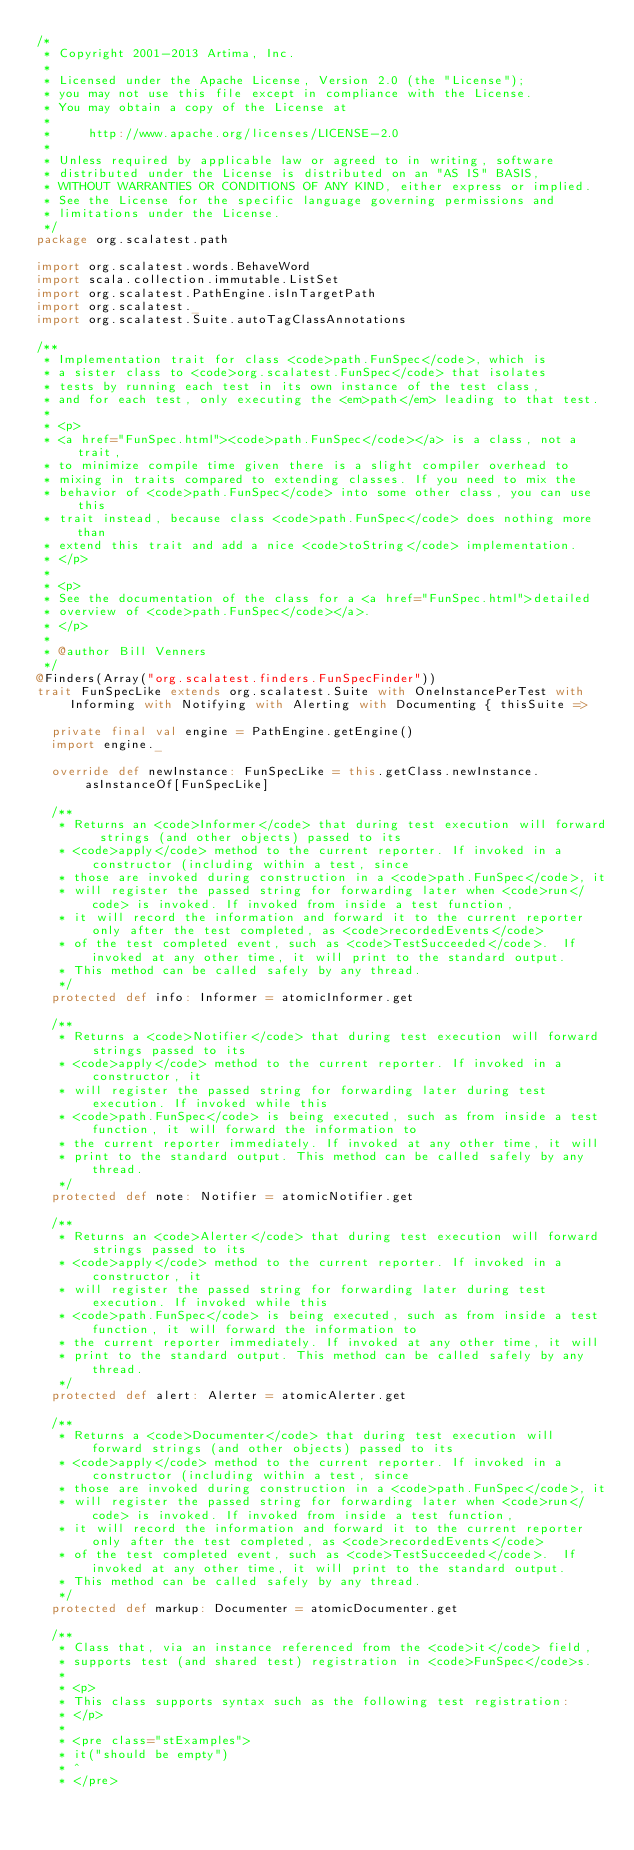Convert code to text. <code><loc_0><loc_0><loc_500><loc_500><_Scala_>/*
 * Copyright 2001-2013 Artima, Inc.
 *
 * Licensed under the Apache License, Version 2.0 (the "License");
 * you may not use this file except in compliance with the License.
 * You may obtain a copy of the License at
 *
 *     http://www.apache.org/licenses/LICENSE-2.0
 *
 * Unless required by applicable law or agreed to in writing, software
 * distributed under the License is distributed on an "AS IS" BASIS,
 * WITHOUT WARRANTIES OR CONDITIONS OF ANY KIND, either express or implied.
 * See the License for the specific language governing permissions and
 * limitations under the License.
 */
package org.scalatest.path

import org.scalatest.words.BehaveWord
import scala.collection.immutable.ListSet
import org.scalatest.PathEngine.isInTargetPath
import org.scalatest._
import org.scalatest.Suite.autoTagClassAnnotations

/**
 * Implementation trait for class <code>path.FunSpec</code>, which is
 * a sister class to <code>org.scalatest.FunSpec</code> that isolates
 * tests by running each test in its own instance of the test class,
 * and for each test, only executing the <em>path</em> leading to that test.
 * 
 * <p>
 * <a href="FunSpec.html"><code>path.FunSpec</code></a> is a class, not a trait,
 * to minimize compile time given there is a slight compiler overhead to
 * mixing in traits compared to extending classes. If you need to mix the
 * behavior of <code>path.FunSpec</code> into some other class, you can use this
 * trait instead, because class <code>path.FunSpec</code> does nothing more than
 * extend this trait and add a nice <code>toString</code> implementation.
 * </p>
 *
 * <p>
 * See the documentation of the class for a <a href="FunSpec.html">detailed
 * overview of <code>path.FunSpec</code></a>.
 * </p>
 *
 * @author Bill Venners
 */
@Finders(Array("org.scalatest.finders.FunSpecFinder"))
trait FunSpecLike extends org.scalatest.Suite with OneInstancePerTest with Informing with Notifying with Alerting with Documenting { thisSuite =>
  
  private final val engine = PathEngine.getEngine()
  import engine._

  override def newInstance: FunSpecLike = this.getClass.newInstance.asInstanceOf[FunSpecLike]

  /**
   * Returns an <code>Informer</code> that during test execution will forward strings (and other objects) passed to its
   * <code>apply</code> method to the current reporter. If invoked in a constructor (including within a test, since
   * those are invoked during construction in a <code>path.FunSpec</code>, it
   * will register the passed string for forwarding later when <code>run</code> is invoked. If invoked from inside a test function,
   * it will record the information and forward it to the current reporter only after the test completed, as <code>recordedEvents</code>
   * of the test completed event, such as <code>TestSucceeded</code>.  If invoked at any other time, it will print to the standard output.
   * This method can be called safely by any thread.
   */
  protected def info: Informer = atomicInformer.get

  /**
   * Returns a <code>Notifier</code> that during test execution will forward strings passed to its
   * <code>apply</code> method to the current reporter. If invoked in a constructor, it
   * will register the passed string for forwarding later during test execution. If invoked while this
   * <code>path.FunSpec</code> is being executed, such as from inside a test function, it will forward the information to
   * the current reporter immediately. If invoked at any other time, it will
   * print to the standard output. This method can be called safely by any thread.
   */
  protected def note: Notifier = atomicNotifier.get

  /**
   * Returns an <code>Alerter</code> that during test execution will forward strings passed to its
   * <code>apply</code> method to the current reporter. If invoked in a constructor, it
   * will register the passed string for forwarding later during test execution. If invoked while this
   * <code>path.FunSpec</code> is being executed, such as from inside a test function, it will forward the information to
   * the current reporter immediately. If invoked at any other time, it will
   * print to the standard output. This method can be called safely by any thread.
   */
  protected def alert: Alerter = atomicAlerter.get

  /**
   * Returns a <code>Documenter</code> that during test execution will forward strings (and other objects) passed to its
   * <code>apply</code> method to the current reporter. If invoked in a constructor (including within a test, since
   * those are invoked during construction in a <code>path.FunSpec</code>, it
   * will register the passed string for forwarding later when <code>run</code> is invoked. If invoked from inside a test function,
   * it will record the information and forward it to the current reporter only after the test completed, as <code>recordedEvents</code>
   * of the test completed event, such as <code>TestSucceeded</code>.  If invoked at any other time, it will print to the standard output.
   * This method can be called safely by any thread.
   */
  protected def markup: Documenter = atomicDocumenter.get

  /**
   * Class that, via an instance referenced from the <code>it</code> field,
   * supports test (and shared test) registration in <code>FunSpec</code>s.
   *
   * <p>
   * This class supports syntax such as the following test registration:
   * </p>
   *
   * <pre class="stExamples">
   * it("should be empty")
   * ^
   * </pre></code> 